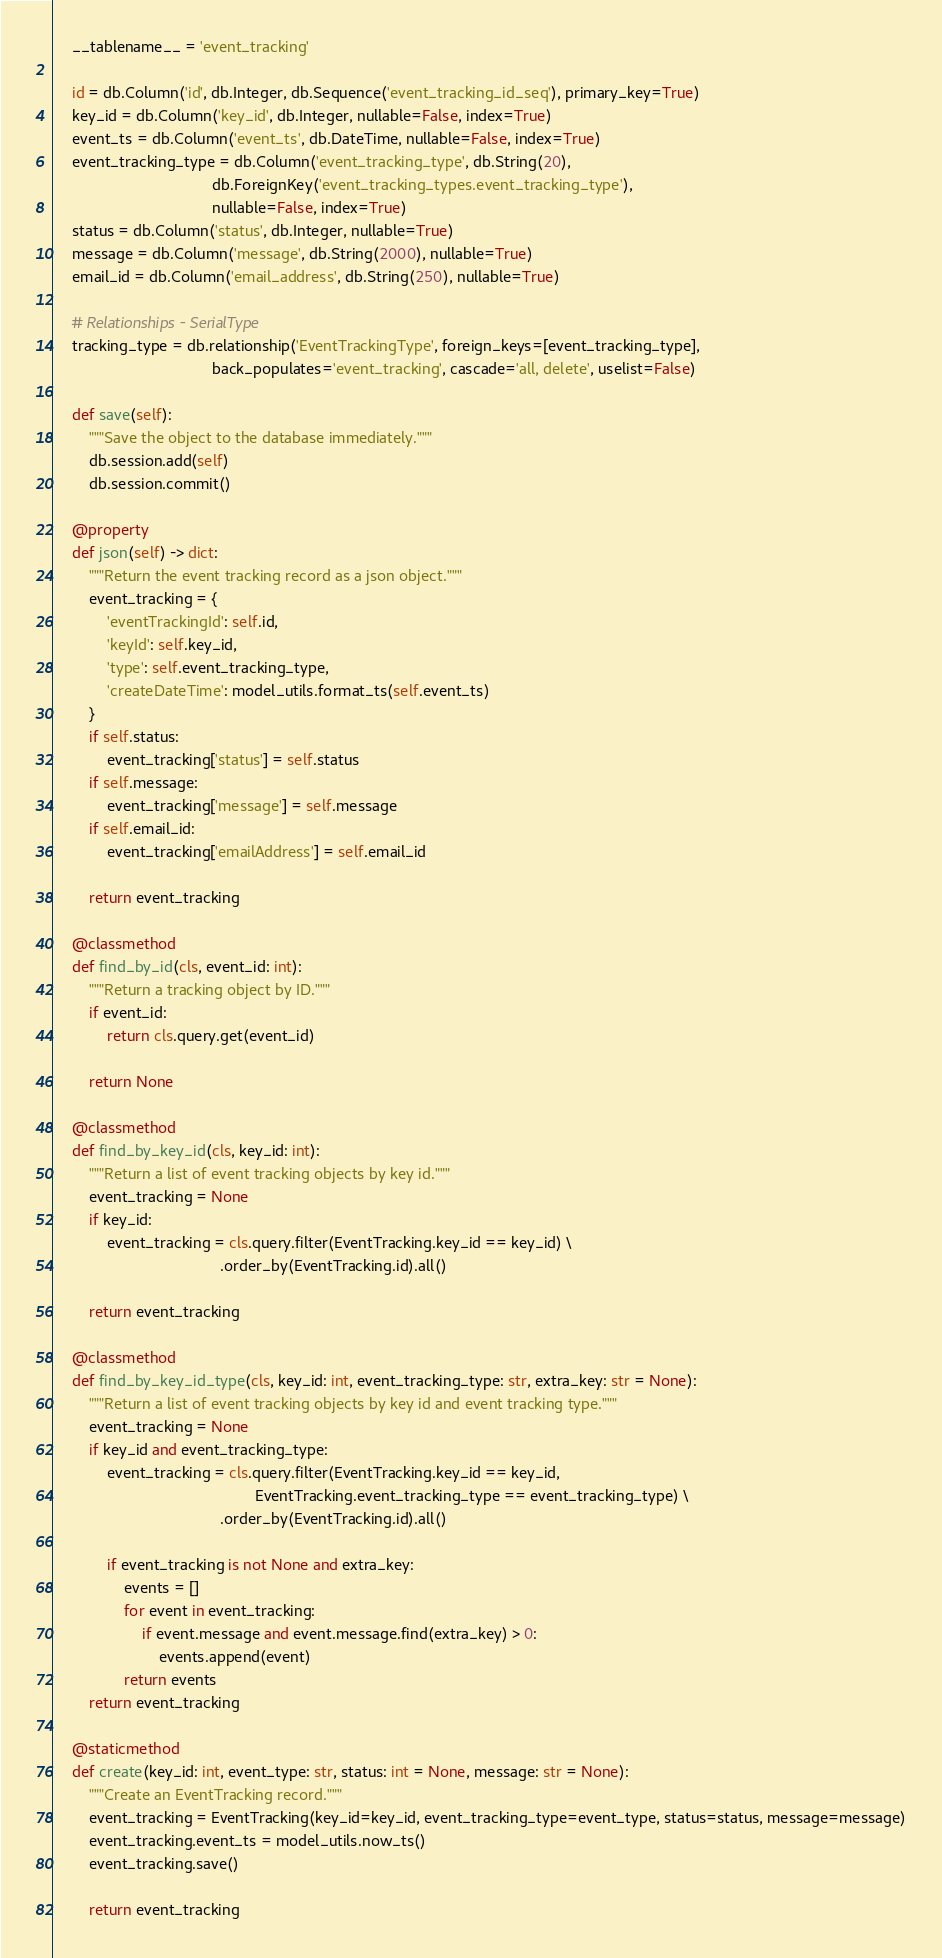Convert code to text. <code><loc_0><loc_0><loc_500><loc_500><_Python_>    __tablename__ = 'event_tracking'

    id = db.Column('id', db.Integer, db.Sequence('event_tracking_id_seq'), primary_key=True)
    key_id = db.Column('key_id', db.Integer, nullable=False, index=True)
    event_ts = db.Column('event_ts', db.DateTime, nullable=False, index=True)
    event_tracking_type = db.Column('event_tracking_type', db.String(20),
                                    db.ForeignKey('event_tracking_types.event_tracking_type'),
                                    nullable=False, index=True)
    status = db.Column('status', db.Integer, nullable=True)
    message = db.Column('message', db.String(2000), nullable=True)
    email_id = db.Column('email_address', db.String(250), nullable=True)

    # Relationships - SerialType
    tracking_type = db.relationship('EventTrackingType', foreign_keys=[event_tracking_type],
                                    back_populates='event_tracking', cascade='all, delete', uselist=False)

    def save(self):
        """Save the object to the database immediately."""
        db.session.add(self)
        db.session.commit()

    @property
    def json(self) -> dict:
        """Return the event tracking record as a json object."""
        event_tracking = {
            'eventTrackingId': self.id,
            'keyId': self.key_id,
            'type': self.event_tracking_type,
            'createDateTime': model_utils.format_ts(self.event_ts)
        }
        if self.status:
            event_tracking['status'] = self.status
        if self.message:
            event_tracking['message'] = self.message
        if self.email_id:
            event_tracking['emailAddress'] = self.email_id

        return event_tracking

    @classmethod
    def find_by_id(cls, event_id: int):
        """Return a tracking object by ID."""
        if event_id:
            return cls.query.get(event_id)

        return None

    @classmethod
    def find_by_key_id(cls, key_id: int):
        """Return a list of event tracking objects by key id."""
        event_tracking = None
        if key_id:
            event_tracking = cls.query.filter(EventTracking.key_id == key_id) \
                                      .order_by(EventTracking.id).all()

        return event_tracking

    @classmethod
    def find_by_key_id_type(cls, key_id: int, event_tracking_type: str, extra_key: str = None):
        """Return a list of event tracking objects by key id and event tracking type."""
        event_tracking = None
        if key_id and event_tracking_type:
            event_tracking = cls.query.filter(EventTracking.key_id == key_id,
                                              EventTracking.event_tracking_type == event_tracking_type) \
                                      .order_by(EventTracking.id).all()

            if event_tracking is not None and extra_key:
                events = []
                for event in event_tracking:
                    if event.message and event.message.find(extra_key) > 0:
                        events.append(event)
                return events
        return event_tracking

    @staticmethod
    def create(key_id: int, event_type: str, status: int = None, message: str = None):
        """Create an EventTracking record."""
        event_tracking = EventTracking(key_id=key_id, event_tracking_type=event_type, status=status, message=message)
        event_tracking.event_ts = model_utils.now_ts()
        event_tracking.save()

        return event_tracking
</code> 